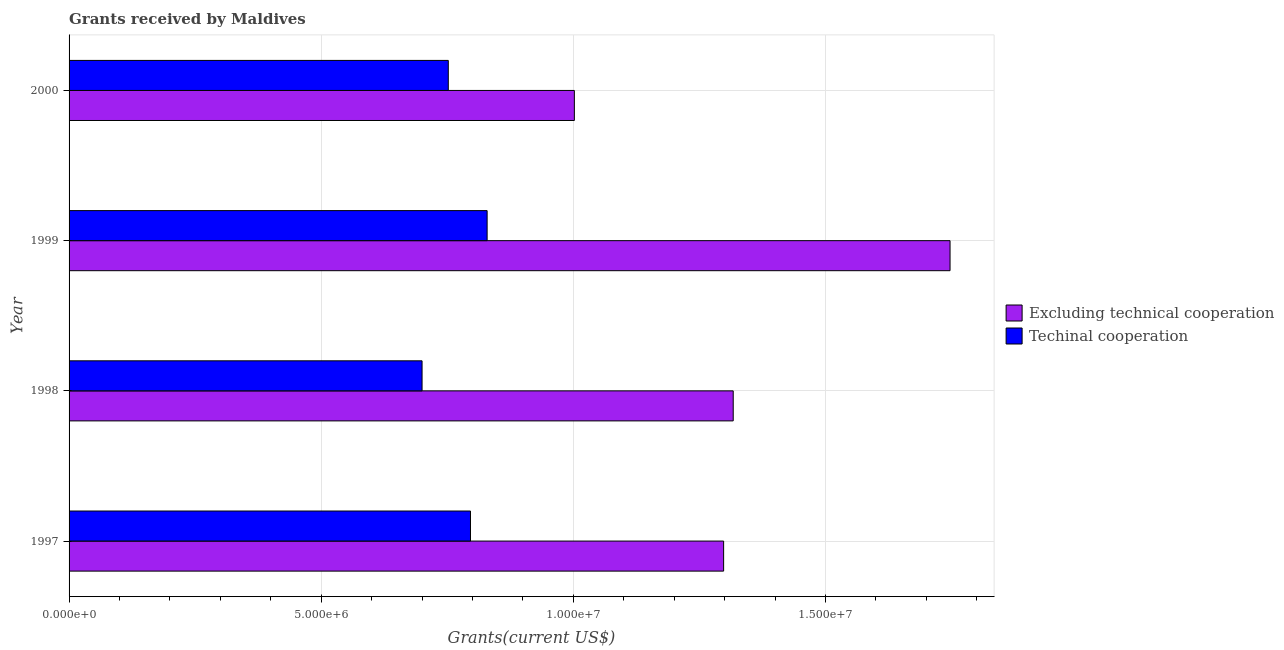How many groups of bars are there?
Keep it short and to the point. 4. Are the number of bars on each tick of the Y-axis equal?
Make the answer very short. Yes. How many bars are there on the 3rd tick from the top?
Provide a succinct answer. 2. What is the amount of grants received(excluding technical cooperation) in 1999?
Offer a very short reply. 1.75e+07. Across all years, what is the maximum amount of grants received(excluding technical cooperation)?
Offer a terse response. 1.75e+07. Across all years, what is the minimum amount of grants received(including technical cooperation)?
Your answer should be very brief. 7.00e+06. In which year was the amount of grants received(excluding technical cooperation) minimum?
Give a very brief answer. 2000. What is the total amount of grants received(excluding technical cooperation) in the graph?
Your response must be concise. 5.36e+07. What is the difference between the amount of grants received(excluding technical cooperation) in 1998 and that in 2000?
Provide a succinct answer. 3.15e+06. What is the difference between the amount of grants received(including technical cooperation) in 1997 and the amount of grants received(excluding technical cooperation) in 1998?
Your response must be concise. -5.21e+06. What is the average amount of grants received(excluding technical cooperation) per year?
Make the answer very short. 1.34e+07. In the year 1997, what is the difference between the amount of grants received(excluding technical cooperation) and amount of grants received(including technical cooperation)?
Provide a succinct answer. 5.02e+06. In how many years, is the amount of grants received(including technical cooperation) greater than 16000000 US$?
Your answer should be very brief. 0. What is the ratio of the amount of grants received(excluding technical cooperation) in 1997 to that in 1999?
Provide a succinct answer. 0.74. Is the amount of grants received(including technical cooperation) in 1999 less than that in 2000?
Provide a succinct answer. No. What is the difference between the highest and the second highest amount of grants received(excluding technical cooperation)?
Make the answer very short. 4.30e+06. What is the difference between the highest and the lowest amount of grants received(including technical cooperation)?
Keep it short and to the point. 1.29e+06. In how many years, is the amount of grants received(including technical cooperation) greater than the average amount of grants received(including technical cooperation) taken over all years?
Provide a short and direct response. 2. What does the 2nd bar from the top in 2000 represents?
Make the answer very short. Excluding technical cooperation. What does the 2nd bar from the bottom in 1997 represents?
Offer a terse response. Techinal cooperation. Are all the bars in the graph horizontal?
Give a very brief answer. Yes. What is the difference between two consecutive major ticks on the X-axis?
Offer a terse response. 5.00e+06. Does the graph contain any zero values?
Give a very brief answer. No. Where does the legend appear in the graph?
Make the answer very short. Center right. How many legend labels are there?
Provide a short and direct response. 2. How are the legend labels stacked?
Ensure brevity in your answer.  Vertical. What is the title of the graph?
Offer a very short reply. Grants received by Maldives. What is the label or title of the X-axis?
Your response must be concise. Grants(current US$). What is the Grants(current US$) of Excluding technical cooperation in 1997?
Offer a terse response. 1.30e+07. What is the Grants(current US$) in Techinal cooperation in 1997?
Keep it short and to the point. 7.96e+06. What is the Grants(current US$) of Excluding technical cooperation in 1998?
Make the answer very short. 1.32e+07. What is the Grants(current US$) of Techinal cooperation in 1998?
Your answer should be very brief. 7.00e+06. What is the Grants(current US$) in Excluding technical cooperation in 1999?
Make the answer very short. 1.75e+07. What is the Grants(current US$) of Techinal cooperation in 1999?
Your answer should be very brief. 8.29e+06. What is the Grants(current US$) of Excluding technical cooperation in 2000?
Keep it short and to the point. 1.00e+07. What is the Grants(current US$) of Techinal cooperation in 2000?
Your answer should be very brief. 7.52e+06. Across all years, what is the maximum Grants(current US$) in Excluding technical cooperation?
Your answer should be very brief. 1.75e+07. Across all years, what is the maximum Grants(current US$) in Techinal cooperation?
Provide a short and direct response. 8.29e+06. Across all years, what is the minimum Grants(current US$) in Excluding technical cooperation?
Offer a terse response. 1.00e+07. What is the total Grants(current US$) of Excluding technical cooperation in the graph?
Your response must be concise. 5.36e+07. What is the total Grants(current US$) of Techinal cooperation in the graph?
Provide a short and direct response. 3.08e+07. What is the difference between the Grants(current US$) in Techinal cooperation in 1997 and that in 1998?
Provide a short and direct response. 9.60e+05. What is the difference between the Grants(current US$) of Excluding technical cooperation in 1997 and that in 1999?
Give a very brief answer. -4.49e+06. What is the difference between the Grants(current US$) in Techinal cooperation in 1997 and that in 1999?
Keep it short and to the point. -3.30e+05. What is the difference between the Grants(current US$) of Excluding technical cooperation in 1997 and that in 2000?
Keep it short and to the point. 2.96e+06. What is the difference between the Grants(current US$) in Techinal cooperation in 1997 and that in 2000?
Give a very brief answer. 4.40e+05. What is the difference between the Grants(current US$) of Excluding technical cooperation in 1998 and that in 1999?
Your response must be concise. -4.30e+06. What is the difference between the Grants(current US$) in Techinal cooperation in 1998 and that in 1999?
Provide a succinct answer. -1.29e+06. What is the difference between the Grants(current US$) in Excluding technical cooperation in 1998 and that in 2000?
Give a very brief answer. 3.15e+06. What is the difference between the Grants(current US$) in Techinal cooperation in 1998 and that in 2000?
Keep it short and to the point. -5.20e+05. What is the difference between the Grants(current US$) in Excluding technical cooperation in 1999 and that in 2000?
Your answer should be compact. 7.45e+06. What is the difference between the Grants(current US$) of Techinal cooperation in 1999 and that in 2000?
Keep it short and to the point. 7.70e+05. What is the difference between the Grants(current US$) of Excluding technical cooperation in 1997 and the Grants(current US$) of Techinal cooperation in 1998?
Keep it short and to the point. 5.98e+06. What is the difference between the Grants(current US$) of Excluding technical cooperation in 1997 and the Grants(current US$) of Techinal cooperation in 1999?
Offer a very short reply. 4.69e+06. What is the difference between the Grants(current US$) of Excluding technical cooperation in 1997 and the Grants(current US$) of Techinal cooperation in 2000?
Your response must be concise. 5.46e+06. What is the difference between the Grants(current US$) in Excluding technical cooperation in 1998 and the Grants(current US$) in Techinal cooperation in 1999?
Your response must be concise. 4.88e+06. What is the difference between the Grants(current US$) in Excluding technical cooperation in 1998 and the Grants(current US$) in Techinal cooperation in 2000?
Your answer should be compact. 5.65e+06. What is the difference between the Grants(current US$) in Excluding technical cooperation in 1999 and the Grants(current US$) in Techinal cooperation in 2000?
Provide a succinct answer. 9.95e+06. What is the average Grants(current US$) in Excluding technical cooperation per year?
Your answer should be compact. 1.34e+07. What is the average Grants(current US$) in Techinal cooperation per year?
Ensure brevity in your answer.  7.69e+06. In the year 1997, what is the difference between the Grants(current US$) in Excluding technical cooperation and Grants(current US$) in Techinal cooperation?
Offer a terse response. 5.02e+06. In the year 1998, what is the difference between the Grants(current US$) in Excluding technical cooperation and Grants(current US$) in Techinal cooperation?
Your response must be concise. 6.17e+06. In the year 1999, what is the difference between the Grants(current US$) in Excluding technical cooperation and Grants(current US$) in Techinal cooperation?
Your answer should be compact. 9.18e+06. In the year 2000, what is the difference between the Grants(current US$) in Excluding technical cooperation and Grants(current US$) in Techinal cooperation?
Your answer should be very brief. 2.50e+06. What is the ratio of the Grants(current US$) of Excluding technical cooperation in 1997 to that in 1998?
Offer a very short reply. 0.99. What is the ratio of the Grants(current US$) of Techinal cooperation in 1997 to that in 1998?
Your answer should be compact. 1.14. What is the ratio of the Grants(current US$) of Excluding technical cooperation in 1997 to that in 1999?
Provide a succinct answer. 0.74. What is the ratio of the Grants(current US$) in Techinal cooperation in 1997 to that in 1999?
Offer a very short reply. 0.96. What is the ratio of the Grants(current US$) in Excluding technical cooperation in 1997 to that in 2000?
Ensure brevity in your answer.  1.3. What is the ratio of the Grants(current US$) in Techinal cooperation in 1997 to that in 2000?
Your response must be concise. 1.06. What is the ratio of the Grants(current US$) of Excluding technical cooperation in 1998 to that in 1999?
Give a very brief answer. 0.75. What is the ratio of the Grants(current US$) in Techinal cooperation in 1998 to that in 1999?
Provide a succinct answer. 0.84. What is the ratio of the Grants(current US$) in Excluding technical cooperation in 1998 to that in 2000?
Offer a very short reply. 1.31. What is the ratio of the Grants(current US$) in Techinal cooperation in 1998 to that in 2000?
Your answer should be very brief. 0.93. What is the ratio of the Grants(current US$) in Excluding technical cooperation in 1999 to that in 2000?
Make the answer very short. 1.74. What is the ratio of the Grants(current US$) of Techinal cooperation in 1999 to that in 2000?
Provide a succinct answer. 1.1. What is the difference between the highest and the second highest Grants(current US$) in Excluding technical cooperation?
Provide a short and direct response. 4.30e+06. What is the difference between the highest and the lowest Grants(current US$) in Excluding technical cooperation?
Your response must be concise. 7.45e+06. What is the difference between the highest and the lowest Grants(current US$) of Techinal cooperation?
Ensure brevity in your answer.  1.29e+06. 